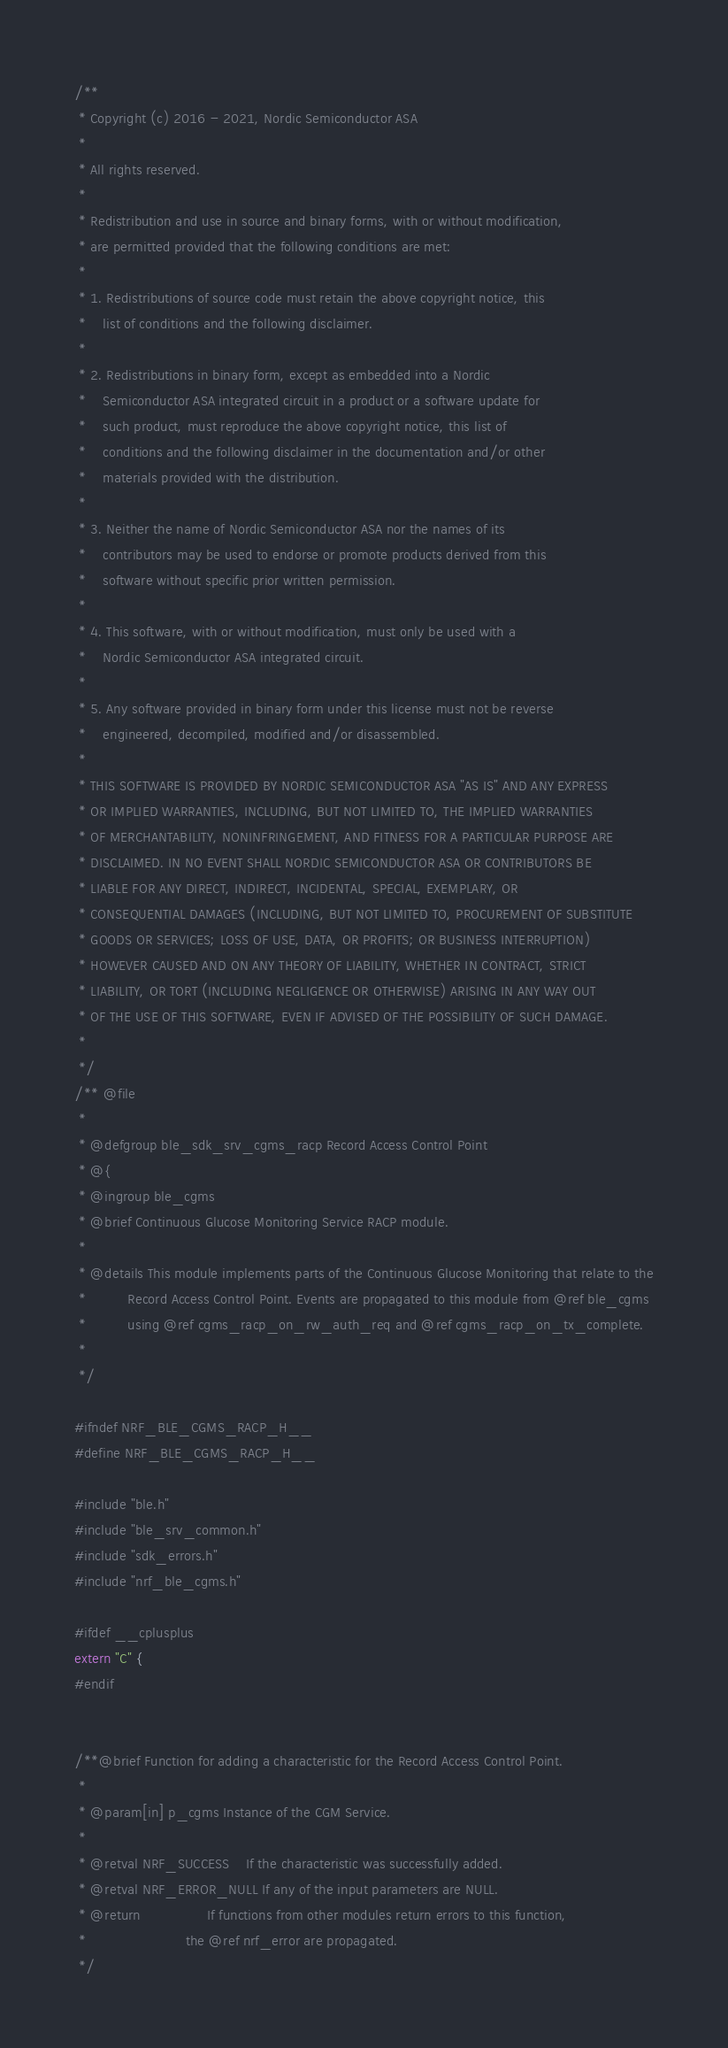<code> <loc_0><loc_0><loc_500><loc_500><_C_>/**
 * Copyright (c) 2016 - 2021, Nordic Semiconductor ASA
 *
 * All rights reserved.
 *
 * Redistribution and use in source and binary forms, with or without modification,
 * are permitted provided that the following conditions are met:
 *
 * 1. Redistributions of source code must retain the above copyright notice, this
 *    list of conditions and the following disclaimer.
 *
 * 2. Redistributions in binary form, except as embedded into a Nordic
 *    Semiconductor ASA integrated circuit in a product or a software update for
 *    such product, must reproduce the above copyright notice, this list of
 *    conditions and the following disclaimer in the documentation and/or other
 *    materials provided with the distribution.
 *
 * 3. Neither the name of Nordic Semiconductor ASA nor the names of its
 *    contributors may be used to endorse or promote products derived from this
 *    software without specific prior written permission.
 *
 * 4. This software, with or without modification, must only be used with a
 *    Nordic Semiconductor ASA integrated circuit.
 *
 * 5. Any software provided in binary form under this license must not be reverse
 *    engineered, decompiled, modified and/or disassembled.
 *
 * THIS SOFTWARE IS PROVIDED BY NORDIC SEMICONDUCTOR ASA "AS IS" AND ANY EXPRESS
 * OR IMPLIED WARRANTIES, INCLUDING, BUT NOT LIMITED TO, THE IMPLIED WARRANTIES
 * OF MERCHANTABILITY, NONINFRINGEMENT, AND FITNESS FOR A PARTICULAR PURPOSE ARE
 * DISCLAIMED. IN NO EVENT SHALL NORDIC SEMICONDUCTOR ASA OR CONTRIBUTORS BE
 * LIABLE FOR ANY DIRECT, INDIRECT, INCIDENTAL, SPECIAL, EXEMPLARY, OR
 * CONSEQUENTIAL DAMAGES (INCLUDING, BUT NOT LIMITED TO, PROCUREMENT OF SUBSTITUTE
 * GOODS OR SERVICES; LOSS OF USE, DATA, OR PROFITS; OR BUSINESS INTERRUPTION)
 * HOWEVER CAUSED AND ON ANY THEORY OF LIABILITY, WHETHER IN CONTRACT, STRICT
 * LIABILITY, OR TORT (INCLUDING NEGLIGENCE OR OTHERWISE) ARISING IN ANY WAY OUT
 * OF THE USE OF THIS SOFTWARE, EVEN IF ADVISED OF THE POSSIBILITY OF SUCH DAMAGE.
 *
 */
/** @file
 *
 * @defgroup ble_sdk_srv_cgms_racp Record Access Control Point
 * @{
 * @ingroup ble_cgms
 * @brief Continuous Glucose Monitoring Service RACP module.
 *
 * @details This module implements parts of the Continuous Glucose Monitoring that relate to the
 *          Record Access Control Point. Events are propagated to this module from @ref ble_cgms
 *          using @ref cgms_racp_on_rw_auth_req and @ref cgms_racp_on_tx_complete.
 *
 */

#ifndef NRF_BLE_CGMS_RACP_H__
#define NRF_BLE_CGMS_RACP_H__

#include "ble.h"
#include "ble_srv_common.h"
#include "sdk_errors.h"
#include "nrf_ble_cgms.h"

#ifdef __cplusplus
extern "C" {
#endif


/**@brief Function for adding a characteristic for the Record Access Control Point.
 *
 * @param[in] p_cgms Instance of the CGM Service.
 *
 * @retval NRF_SUCCESS    If the characteristic was successfully added.
 * @retval NRF_ERROR_NULL If any of the input parameters are NULL.
 * @return                If functions from other modules return errors to this function,
 *                        the @ref nrf_error are propagated.
 */</code> 